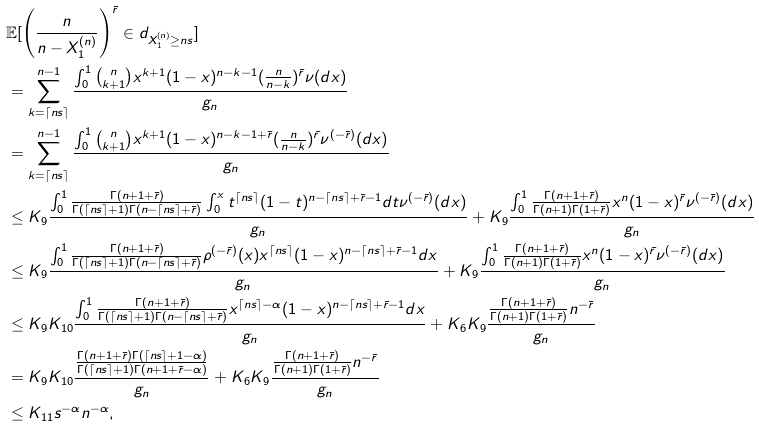<formula> <loc_0><loc_0><loc_500><loc_500>& \mathbb { E } [ \left ( \frac { n } { n - X _ { 1 } ^ { ( n ) } } \right ) ^ { \bar { r } } \in d _ { X _ { 1 } ^ { ( n ) } \geq n s } ] \\ & = \sum _ { k = \lceil n s \rceil } ^ { n - 1 } \frac { \int _ { 0 } ^ { 1 } { n \choose k + 1 } x ^ { k + 1 } ( 1 - x ) ^ { n - k - 1 } ( \frac { n } { n - k } ) ^ { \bar { r } } \nu ( d x ) } { g _ { n } } \\ & = \sum _ { k = \lceil n s \rceil } ^ { n - 1 } \frac { \int _ { 0 } ^ { 1 } { n \choose k + 1 } x ^ { k + 1 } ( 1 - x ) ^ { n - k - 1 + \bar { r } } ( \frac { n } { n - k } ) ^ { \bar { r } } \nu ^ { ( - \bar { r } ) } ( d x ) } { g _ { n } } \\ & \leq K _ { 9 } \frac { \int _ { 0 } ^ { 1 } \frac { \Gamma ( n + 1 + \bar { r } ) } { \Gamma ( \lceil n s \rceil + 1 ) \Gamma ( n - \lceil n s \rceil + \bar { r } ) } \int _ { 0 } ^ { x } t ^ { \lceil n s \rceil } ( 1 - t ) ^ { n - \lceil n s \rceil + \bar { r } - 1 } d t \nu ^ { ( - \bar { r } ) } ( d x ) } { g _ { n } } + K _ { 9 } \frac { \int _ { 0 } ^ { 1 } \frac { \Gamma ( n + 1 + \bar { r } ) } { \Gamma ( n + 1 ) \Gamma ( 1 + \bar { r } ) } x ^ { n } ( 1 - x ) ^ { \bar { r } } \nu ^ { ( - \bar { r } ) } ( d x ) } { g _ { n } } \\ & \leq K _ { 9 } \frac { \int _ { 0 } ^ { 1 } \frac { \Gamma ( n + 1 + \bar { r } ) } { \Gamma ( \lceil n s \rceil + 1 ) \Gamma ( n - \lceil n s \rceil + \bar { r } ) } \rho ^ { ( - \bar { r } ) } ( x ) x ^ { \lceil n s \rceil } ( 1 - x ) ^ { n - \lceil n s \rceil + \bar { r } - 1 } d x } { g _ { n } } + K _ { 9 } \frac { \int _ { 0 } ^ { 1 } \frac { \Gamma ( n + 1 + \bar { r } ) } { \Gamma ( n + 1 ) \Gamma ( 1 + \bar { r } ) } x ^ { n } ( 1 - x ) ^ { \bar { r } } \nu ^ { ( - \bar { r } ) } ( d x ) } { g _ { n } } \\ & \leq K _ { 9 } K _ { 1 0 } \frac { \int _ { 0 } ^ { 1 } \frac { \Gamma ( n + 1 + \bar { r } ) } { \Gamma ( \lceil n s \rceil + 1 ) \Gamma ( n - \lceil n s \rceil + \bar { r } ) } x ^ { \lceil n s \rceil - \alpha } ( 1 - x ) ^ { n - \lceil n s \rceil + \bar { r } - 1 } d x } { g _ { n } } + { K _ { 6 } } K _ { 9 } \frac { \frac { \Gamma ( n + 1 + \bar { r } ) } { \Gamma ( n + 1 ) \Gamma ( 1 + \bar { r } ) } n ^ { - \bar { r } } } { g _ { n } } \\ & = K _ { 9 } K _ { 1 0 } \frac { \frac { \Gamma ( n + 1 + \bar { r } ) \Gamma ( \lceil n s \rceil + 1 - \alpha ) } { \Gamma ( \lceil n s \rceil + 1 ) \Gamma ( n + 1 + \bar { r } - \alpha ) } } { g _ { n } } + { K _ { 6 } } K _ { 9 } \frac { \frac { \Gamma ( n + 1 + \bar { r } ) } { \Gamma ( n + 1 ) \Gamma ( 1 + \bar { r } ) } n ^ { - \bar { r } } } { g _ { n } } \\ & \leq K _ { 1 1 } s ^ { - \alpha } n ^ { - \alpha } ,</formula> 